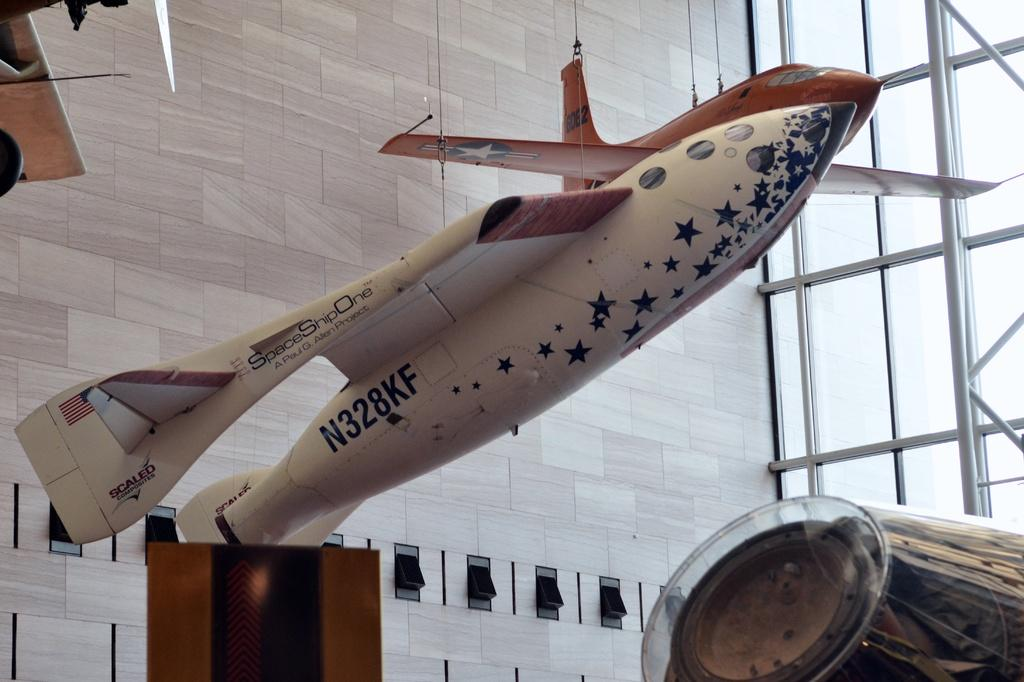<image>
Provide a brief description of the given image. A small plane numbered N328KF suspended in a room 